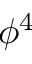<formula> <loc_0><loc_0><loc_500><loc_500>\phi ^ { 4 }</formula> 